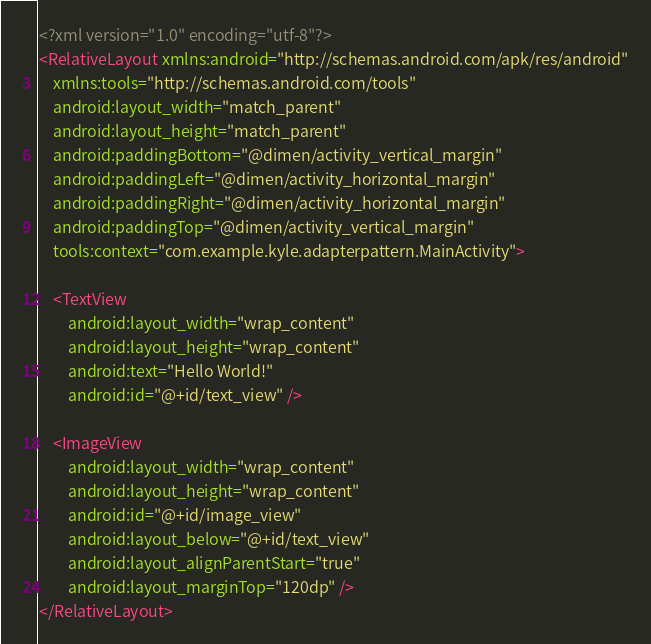Convert code to text. <code><loc_0><loc_0><loc_500><loc_500><_XML_><?xml version="1.0" encoding="utf-8"?>
<RelativeLayout xmlns:android="http://schemas.android.com/apk/res/android"
    xmlns:tools="http://schemas.android.com/tools"
    android:layout_width="match_parent"
    android:layout_height="match_parent"
    android:paddingBottom="@dimen/activity_vertical_margin"
    android:paddingLeft="@dimen/activity_horizontal_margin"
    android:paddingRight="@dimen/activity_horizontal_margin"
    android:paddingTop="@dimen/activity_vertical_margin"
    tools:context="com.example.kyle.adapterpattern.MainActivity">

    <TextView
        android:layout_width="wrap_content"
        android:layout_height="wrap_content"
        android:text="Hello World!"
        android:id="@+id/text_view" />

    <ImageView
        android:layout_width="wrap_content"
        android:layout_height="wrap_content"
        android:id="@+id/image_view"
        android:layout_below="@+id/text_view"
        android:layout_alignParentStart="true"
        android:layout_marginTop="120dp" />
</RelativeLayout>
</code> 